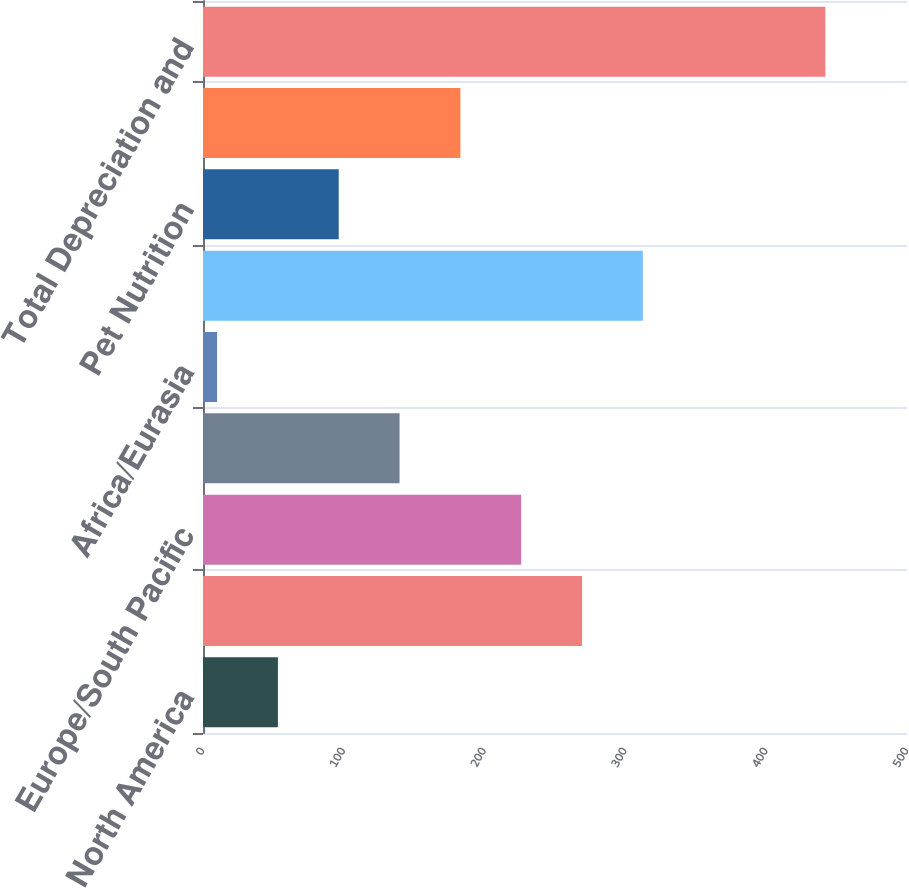Convert chart to OTSL. <chart><loc_0><loc_0><loc_500><loc_500><bar_chart><fcel>North America<fcel>Latin America<fcel>Europe/South Pacific<fcel>Asia<fcel>Africa/Eurasia<fcel>Total Oral Personal and Home<fcel>Pet Nutrition<fcel>Corporate<fcel>Total Depreciation and<nl><fcel>53.2<fcel>269.2<fcel>226<fcel>139.6<fcel>10<fcel>312.4<fcel>96.4<fcel>182.8<fcel>442<nl></chart> 